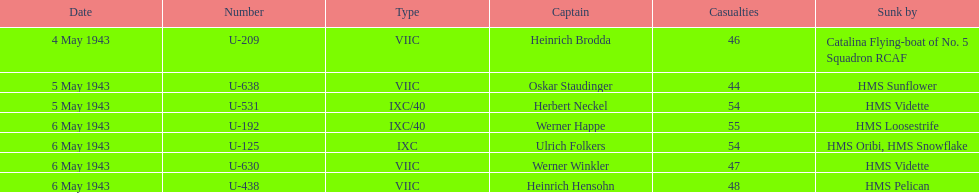What was the only captain sunk by hms pelican? Heinrich Hensohn. 